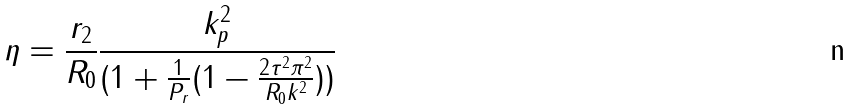Convert formula to latex. <formula><loc_0><loc_0><loc_500><loc_500>\eta = \frac { r _ { 2 } } { R _ { 0 } } \frac { k _ { p } ^ { 2 } } { ( 1 + \frac { 1 } { P _ { r } } ( 1 - \frac { 2 \tau ^ { 2 } \pi ^ { 2 } } { R _ { 0 } k ^ { 2 } } ) ) }</formula> 